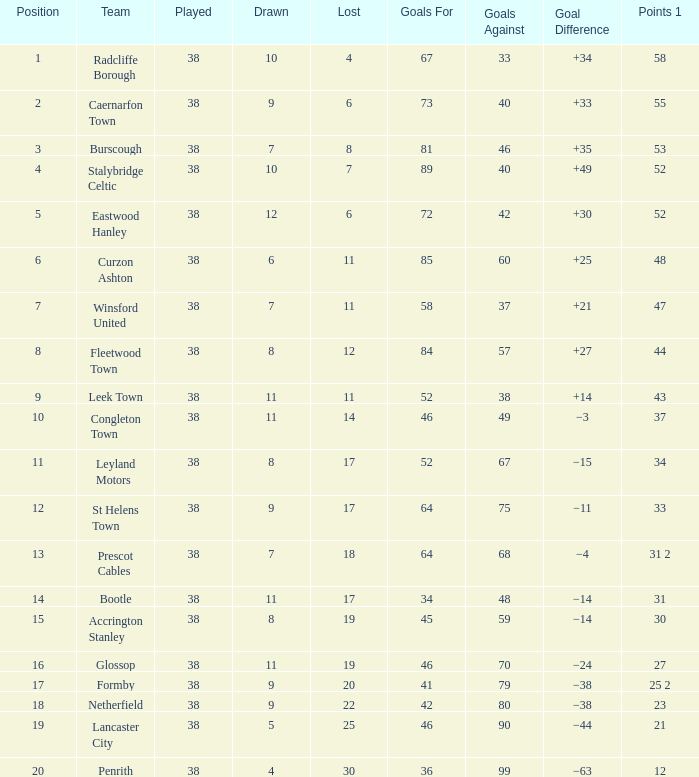WHAT IS THE SUM PLAYED WITH POINTS 1 OF 53, AND POSITION LARGER THAN 3? None. 